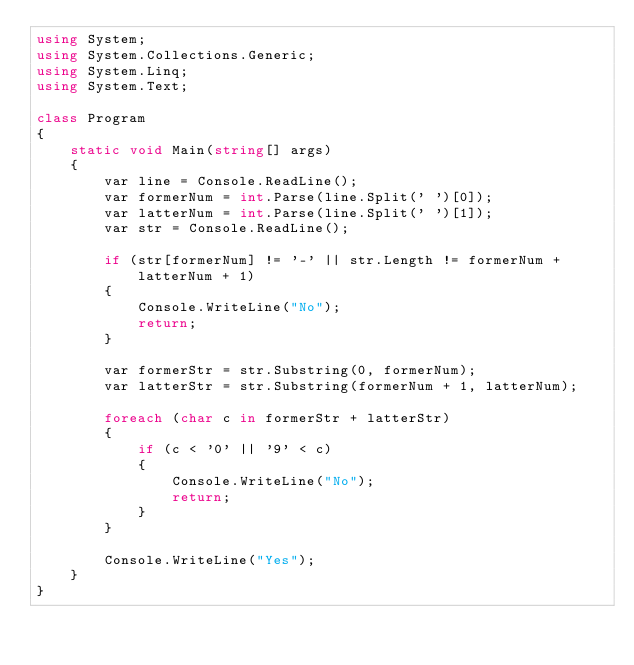<code> <loc_0><loc_0><loc_500><loc_500><_C#_>using System;
using System.Collections.Generic;
using System.Linq;
using System.Text;

class Program
{
    static void Main(string[] args)
    {
        var line = Console.ReadLine();
        var formerNum = int.Parse(line.Split(' ')[0]);
        var latterNum = int.Parse(line.Split(' ')[1]);
        var str = Console.ReadLine();

        if (str[formerNum] != '-' || str.Length != formerNum + latterNum + 1)
        {
            Console.WriteLine("No");
            return;
        }

        var formerStr = str.Substring(0, formerNum);
        var latterStr = str.Substring(formerNum + 1, latterNum);
        
        foreach (char c in formerStr + latterStr)
        {
            if (c < '0' || '9' < c)
            {
                Console.WriteLine("No");
                return;
            }
        }

        Console.WriteLine("Yes");
    }
}</code> 